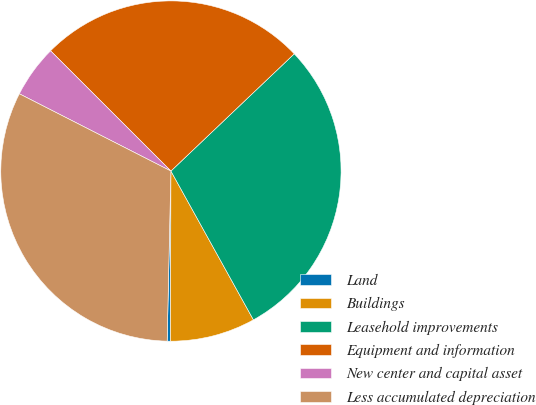Convert chart to OTSL. <chart><loc_0><loc_0><loc_500><loc_500><pie_chart><fcel>Land<fcel>Buildings<fcel>Leasehold improvements<fcel>Equipment and information<fcel>New center and capital asset<fcel>Less accumulated depreciation<nl><fcel>0.31%<fcel>8.1%<fcel>29.04%<fcel>25.41%<fcel>4.99%<fcel>32.15%<nl></chart> 